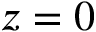Convert formula to latex. <formula><loc_0><loc_0><loc_500><loc_500>z = 0</formula> 